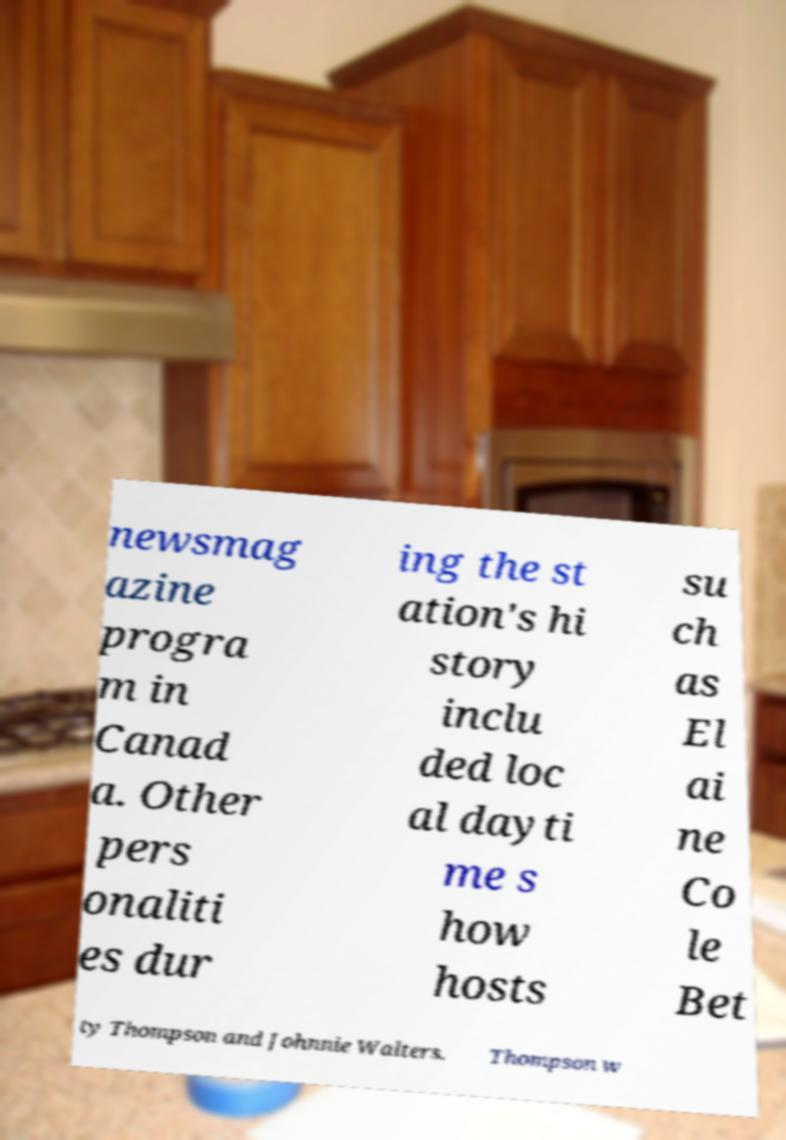Could you assist in decoding the text presented in this image and type it out clearly? newsmag azine progra m in Canad a. Other pers onaliti es dur ing the st ation's hi story inclu ded loc al dayti me s how hosts su ch as El ai ne Co le Bet ty Thompson and Johnnie Walters. Thompson w 